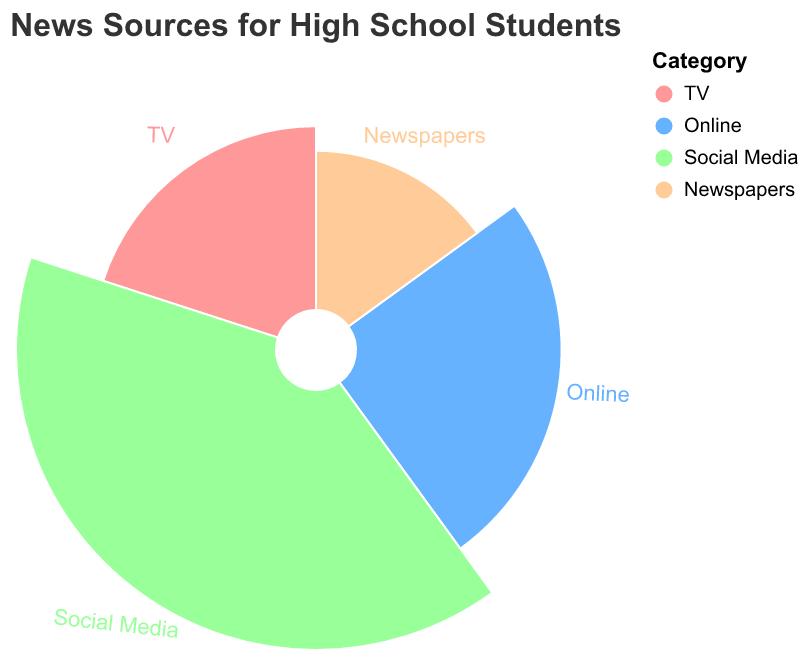What's the title of the figure? The title of the figure is usually placed at the top. In this case, the title is "News Sources for High School Students".
Answer: News Sources for High School Students Which category has the highest percentage? By observing the segments, Social Media occupies the largest area, indicating it has the highest percentage.
Answer: Social Media What percentage of high school students get their news from TV? By looking at the segment labeled "TV", it shows that 20% of high school students get their news from TV.
Answer: 20% How many categories are displayed in the figure? Each segment represents a different category, adding them up shows four segments: TV, Online, Social Media, and Newspapers.
Answer: 4 What is the combined percentage of TV and Online news sources? The percentage for TV is 20% and for Online is 25%. Adding them together, 20% + 25% = 45%.
Answer: 45% Which source is the least popular among high school students? By comparing the size of the segments, Newspapers has the smallest area, indicating it is the least popular source.
Answer: Newspapers How much more popular is Social Media compared to Newspapers? The percentage for Social Media is 40% and for Newspapers is 15%. Subtracting them, 40% - 15% = 25%.
Answer: 25% What are the colors used in the chart to represent the different news sources? The colors used are visible from the segments: TV is light red, Online is blue, Social Media is green, and Newspapers is light orange.
Answer: light red, blue, green, light orange Which two categories have a difference of 10% in their percentages? By examining the segments, Social Media (40%) and Online (25%) have a difference of 40% - 25% = 15%. However, TV (20%) and Newspapers (15%) have a difference of 20% - 15% = 5%. Therefore, it appears no two categories have a difference of exactly 10%.
Answer: None What's the average percentage of news consumption across all sources? The percentages are 20% for TV, 25% for Online, 40% for Social Media, and 15% for Newspapers. Summing them up gives 20% + 25% + 40% + 15% = 100%. Dividing by 4 categories, the average is 100% / 4 = 25%.
Answer: 25% 